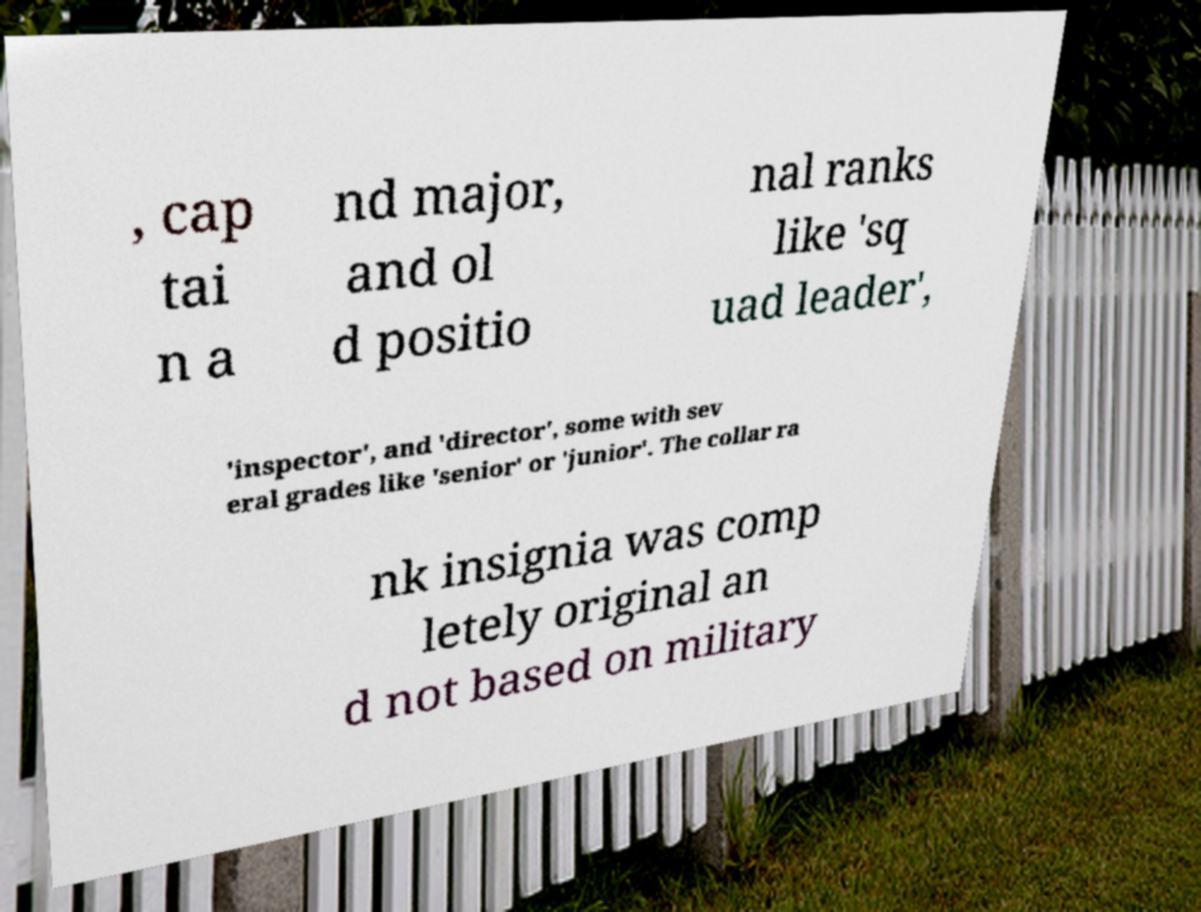Please read and relay the text visible in this image. What does it say? , cap tai n a nd major, and ol d positio nal ranks like 'sq uad leader', 'inspector', and 'director', some with sev eral grades like 'senior' or 'junior'. The collar ra nk insignia was comp letely original an d not based on military 